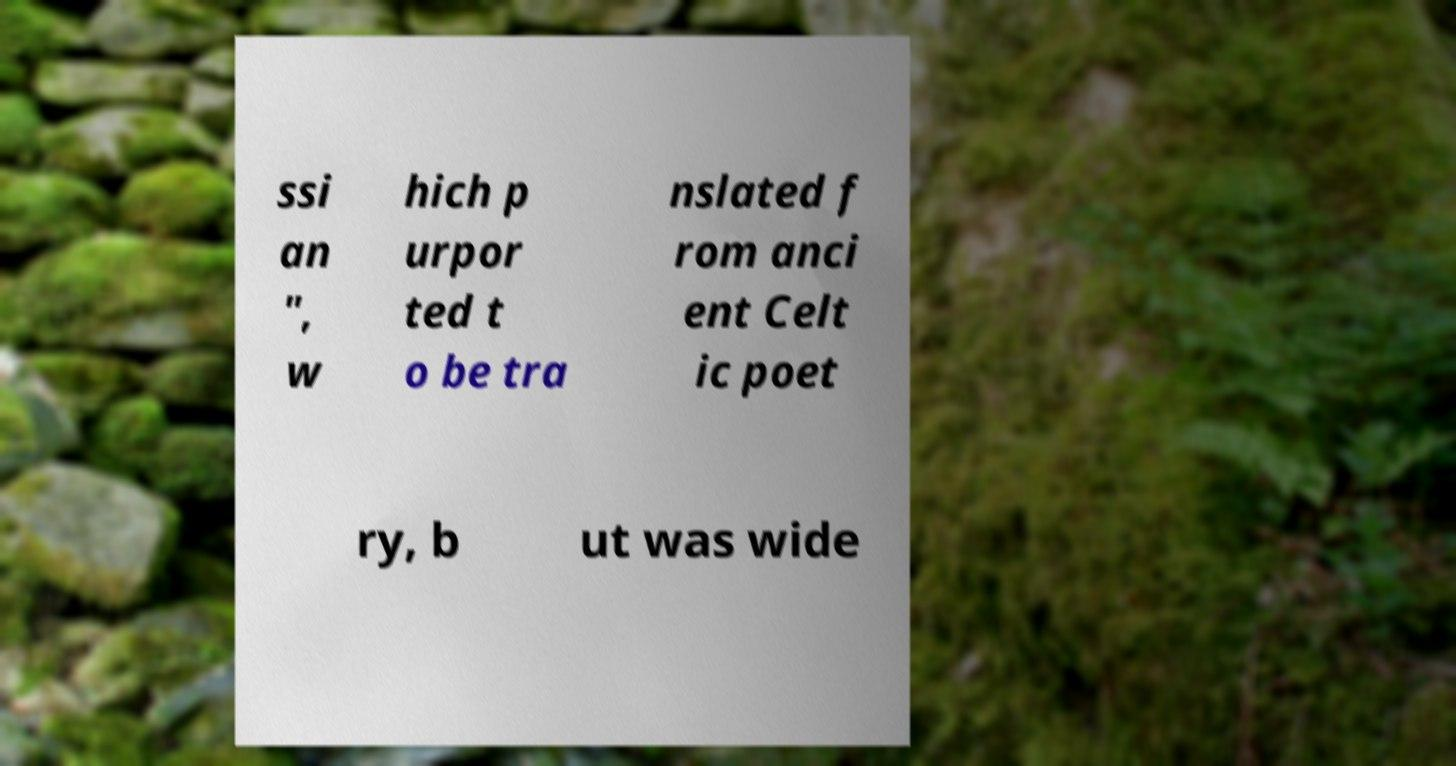Please read and relay the text visible in this image. What does it say? ssi an ", w hich p urpor ted t o be tra nslated f rom anci ent Celt ic poet ry, b ut was wide 